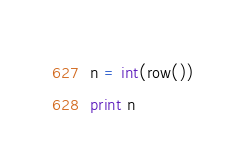<code> <loc_0><loc_0><loc_500><loc_500><_Python_>n = int(row())
print n</code> 